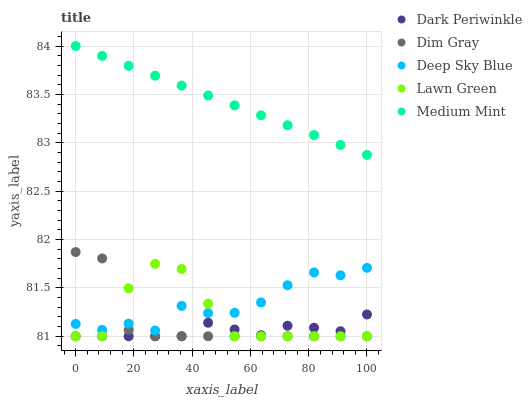Does Dark Periwinkle have the minimum area under the curve?
Answer yes or no. Yes. Does Medium Mint have the maximum area under the curve?
Answer yes or no. Yes. Does Lawn Green have the minimum area under the curve?
Answer yes or no. No. Does Lawn Green have the maximum area under the curve?
Answer yes or no. No. Is Medium Mint the smoothest?
Answer yes or no. Yes. Is Lawn Green the roughest?
Answer yes or no. Yes. Is Dim Gray the smoothest?
Answer yes or no. No. Is Dim Gray the roughest?
Answer yes or no. No. Does Lawn Green have the lowest value?
Answer yes or no. Yes. Does Deep Sky Blue have the lowest value?
Answer yes or no. No. Does Medium Mint have the highest value?
Answer yes or no. Yes. Does Lawn Green have the highest value?
Answer yes or no. No. Is Dark Periwinkle less than Deep Sky Blue?
Answer yes or no. Yes. Is Medium Mint greater than Dark Periwinkle?
Answer yes or no. Yes. Does Dim Gray intersect Dark Periwinkle?
Answer yes or no. Yes. Is Dim Gray less than Dark Periwinkle?
Answer yes or no. No. Is Dim Gray greater than Dark Periwinkle?
Answer yes or no. No. Does Dark Periwinkle intersect Deep Sky Blue?
Answer yes or no. No. 